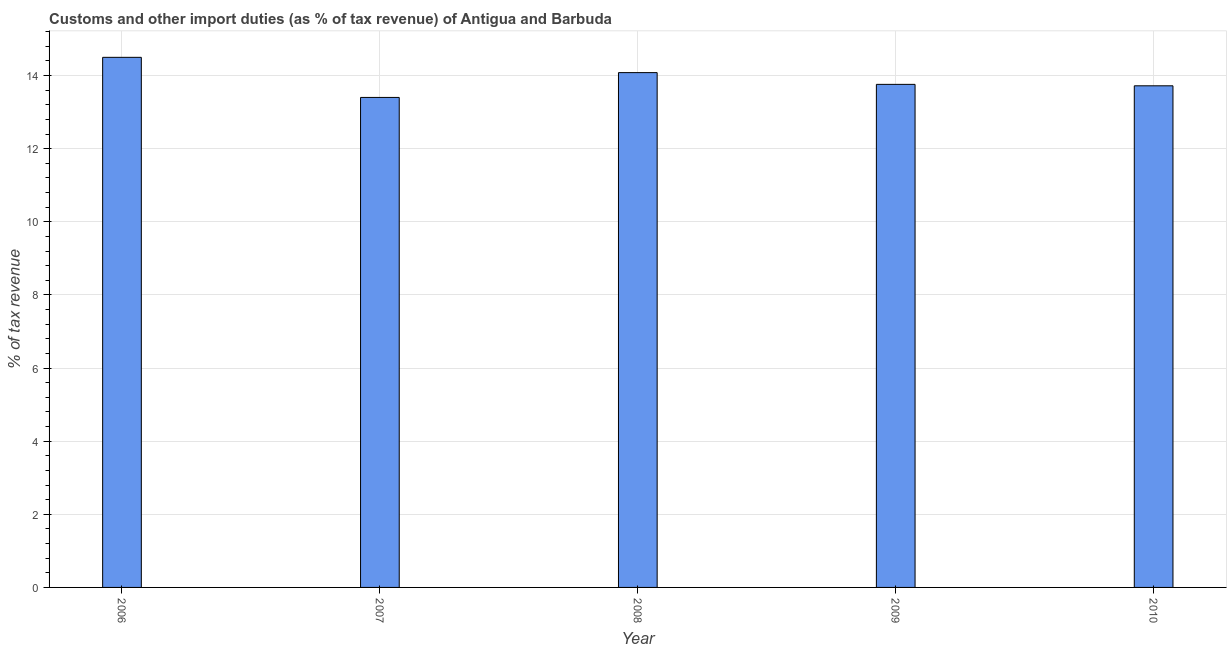Does the graph contain any zero values?
Your response must be concise. No. Does the graph contain grids?
Give a very brief answer. Yes. What is the title of the graph?
Your answer should be compact. Customs and other import duties (as % of tax revenue) of Antigua and Barbuda. What is the label or title of the X-axis?
Provide a short and direct response. Year. What is the label or title of the Y-axis?
Make the answer very short. % of tax revenue. What is the customs and other import duties in 2006?
Make the answer very short. 14.5. Across all years, what is the maximum customs and other import duties?
Keep it short and to the point. 14.5. Across all years, what is the minimum customs and other import duties?
Offer a very short reply. 13.4. In which year was the customs and other import duties maximum?
Your response must be concise. 2006. What is the sum of the customs and other import duties?
Make the answer very short. 69.46. What is the difference between the customs and other import duties in 2009 and 2010?
Give a very brief answer. 0.04. What is the average customs and other import duties per year?
Your answer should be very brief. 13.89. What is the median customs and other import duties?
Make the answer very short. 13.76. What is the ratio of the customs and other import duties in 2007 to that in 2010?
Provide a short and direct response. 0.98. What is the difference between the highest and the second highest customs and other import duties?
Offer a very short reply. 0.42. Is the sum of the customs and other import duties in 2006 and 2007 greater than the maximum customs and other import duties across all years?
Make the answer very short. Yes. In how many years, is the customs and other import duties greater than the average customs and other import duties taken over all years?
Ensure brevity in your answer.  2. How many bars are there?
Ensure brevity in your answer.  5. What is the difference between two consecutive major ticks on the Y-axis?
Keep it short and to the point. 2. Are the values on the major ticks of Y-axis written in scientific E-notation?
Ensure brevity in your answer.  No. What is the % of tax revenue in 2006?
Offer a very short reply. 14.5. What is the % of tax revenue in 2007?
Give a very brief answer. 13.4. What is the % of tax revenue of 2008?
Your answer should be very brief. 14.08. What is the % of tax revenue in 2009?
Provide a succinct answer. 13.76. What is the % of tax revenue in 2010?
Offer a terse response. 13.72. What is the difference between the % of tax revenue in 2006 and 2007?
Offer a very short reply. 1.1. What is the difference between the % of tax revenue in 2006 and 2008?
Keep it short and to the point. 0.42. What is the difference between the % of tax revenue in 2006 and 2009?
Keep it short and to the point. 0.74. What is the difference between the % of tax revenue in 2006 and 2010?
Your answer should be compact. 0.78. What is the difference between the % of tax revenue in 2007 and 2008?
Offer a very short reply. -0.68. What is the difference between the % of tax revenue in 2007 and 2009?
Offer a very short reply. -0.36. What is the difference between the % of tax revenue in 2007 and 2010?
Offer a terse response. -0.32. What is the difference between the % of tax revenue in 2008 and 2009?
Make the answer very short. 0.32. What is the difference between the % of tax revenue in 2008 and 2010?
Your answer should be very brief. 0.36. What is the difference between the % of tax revenue in 2009 and 2010?
Provide a short and direct response. 0.04. What is the ratio of the % of tax revenue in 2006 to that in 2007?
Your answer should be compact. 1.08. What is the ratio of the % of tax revenue in 2006 to that in 2008?
Your answer should be very brief. 1.03. What is the ratio of the % of tax revenue in 2006 to that in 2009?
Your answer should be compact. 1.05. What is the ratio of the % of tax revenue in 2006 to that in 2010?
Your answer should be compact. 1.06. What is the ratio of the % of tax revenue in 2007 to that in 2009?
Your response must be concise. 0.97. What is the ratio of the % of tax revenue in 2007 to that in 2010?
Offer a terse response. 0.98. What is the ratio of the % of tax revenue in 2008 to that in 2009?
Offer a terse response. 1.02. 